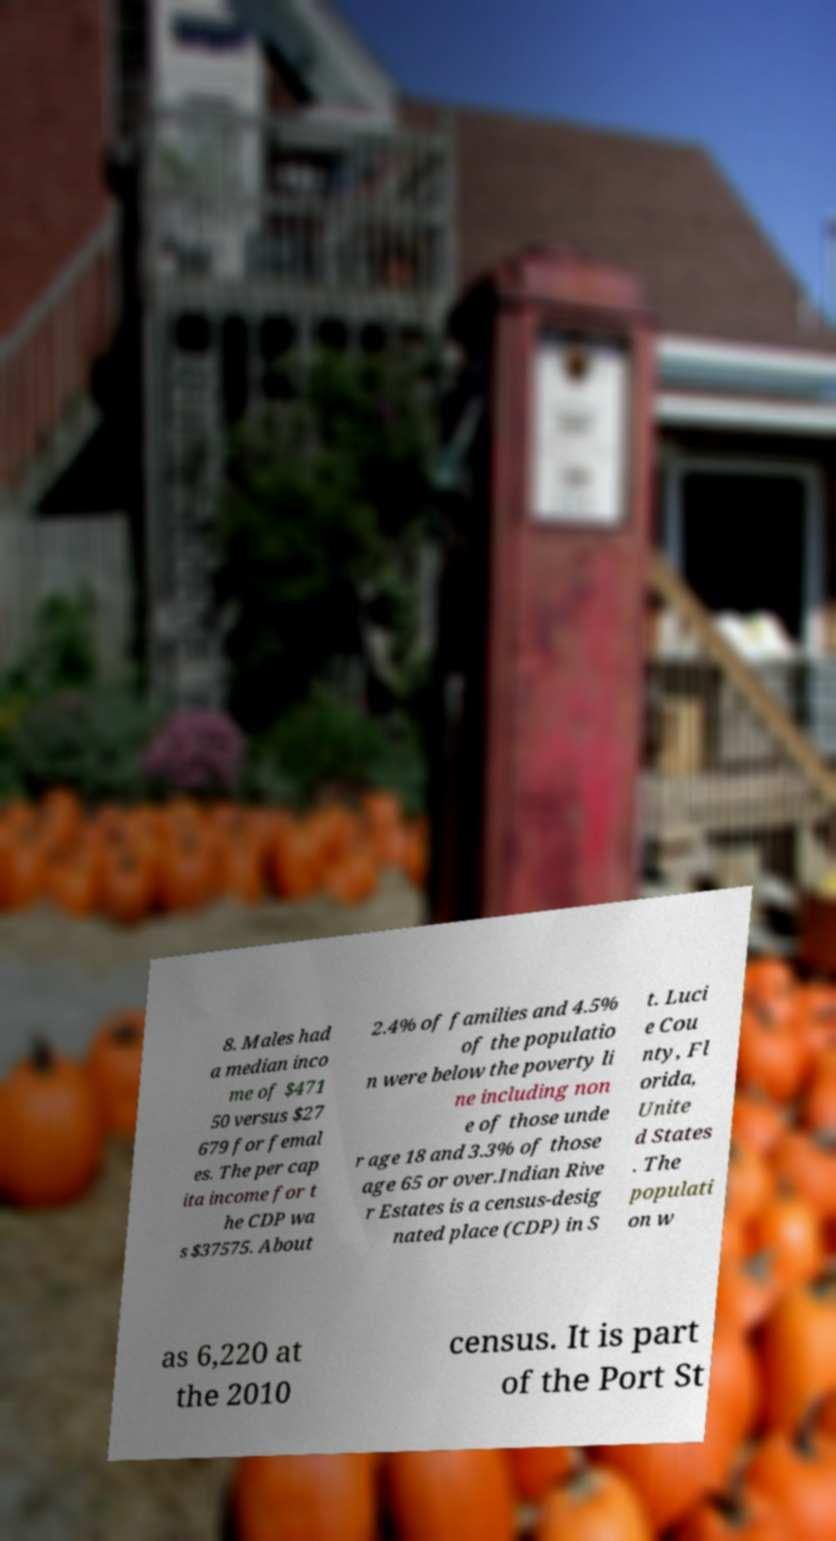Please identify and transcribe the text found in this image. 8. Males had a median inco me of $471 50 versus $27 679 for femal es. The per cap ita income for t he CDP wa s $37575. About 2.4% of families and 4.5% of the populatio n were below the poverty li ne including non e of those unde r age 18 and 3.3% of those age 65 or over.Indian Rive r Estates is a census-desig nated place (CDP) in S t. Luci e Cou nty, Fl orida, Unite d States . The populati on w as 6,220 at the 2010 census. It is part of the Port St 